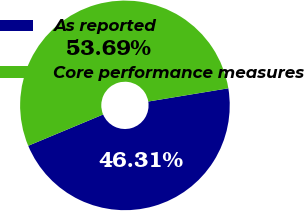<chart> <loc_0><loc_0><loc_500><loc_500><pie_chart><fcel>As reported<fcel>Core performance measures<nl><fcel>46.31%<fcel>53.69%<nl></chart> 